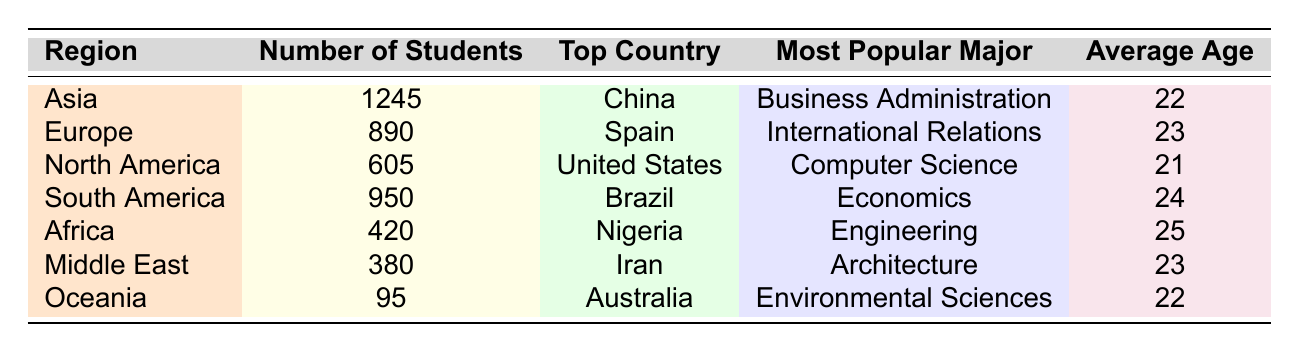What region has the highest number of international students? The table lists the number of students from each region, and the highest number is found in Asia, with 1245 students.
Answer: Asia Which country is listed as having the most students from North America? According to the table, the top country in North America is the United States, with 605 students.
Answer: United States What is the average age of students from South America? The table specifies that the average age of students from South America is 24 years.
Answer: 24 How many total international students are listed from all regions? To calculate the total, we sum the number of students from each region: 1245 + 890 + 605 + 950 + 420 + 380 + 95 = 4385.
Answer: 4385 Is Nigeria the top country for international students in Africa based on the table? Yes, the table shows Nigeria as the top country in Africa with 420 students.
Answer: Yes What is the most popular major for students from Europe? The table indicates that the most popular major for students from Europe is International Relations.
Answer: International Relations How does the average age of students from Africa compare to that of students from Asia? The average age in Africa is 25, while in Asia, it is 22. Therefore, the average age in Africa is higher by 3 years.
Answer: 3 years higher Which region has the least number of international students? By reviewing the table, we see that Oceania has the least number of international students, with only 95.
Answer: Oceania What is the difference in the number of students between Asia and South America? To find the difference, we subtract the number of students in South America (950) from those in Asia (1245): 1245 - 950 = 295.
Answer: 295 Is the average age of students from Oceania lower than the average age of students from Europe? The average age in Oceania is 22 and in Europe is 23, making Oceania's average age lower by 1 year.
Answer: Yes 